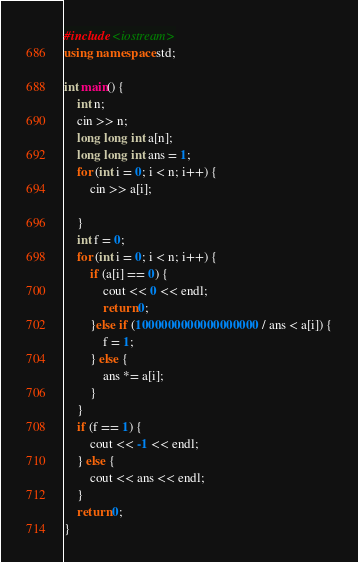Convert code to text. <code><loc_0><loc_0><loc_500><loc_500><_C++_>#include <iostream>
using namespace std;

int main() {
	int n;
	cin >> n;
	long long int a[n];
	long long int ans = 1;
	for (int i = 0; i < n; i++) {
		cin >> a[i];

	}
	int f = 0;
	for (int i = 0; i < n; i++) {
		if (a[i] == 0) {
			cout << 0 << endl;
			return 0;
		}else if (1000000000000000000 / ans < a[i]) {
			f = 1;
		} else {
			ans *= a[i];
		}
	}
	if (f == 1) {
		cout << -1 << endl;
	} else {
		cout << ans << endl;
	}
	return 0;
}
</code> 